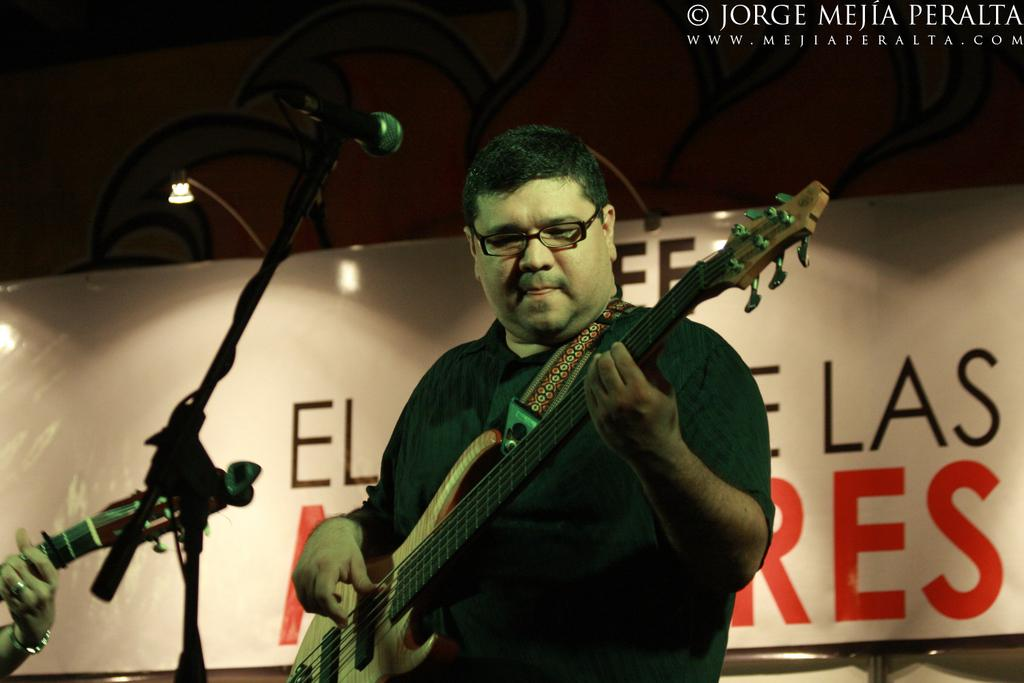What is the man in the image doing? The man is playing a guitar in the image. What is the name of the man in the image? The man's name is Mike. What can be seen in the background of the image? There is a banner and a light in the background of the image. What type of rifle is the man holding in the image? There is no rifle present in the image; the man is playing a guitar. How does the pipe connect to the banner in the image? There is no pipe present in the image; only a banner and a light can be seen in the background. 